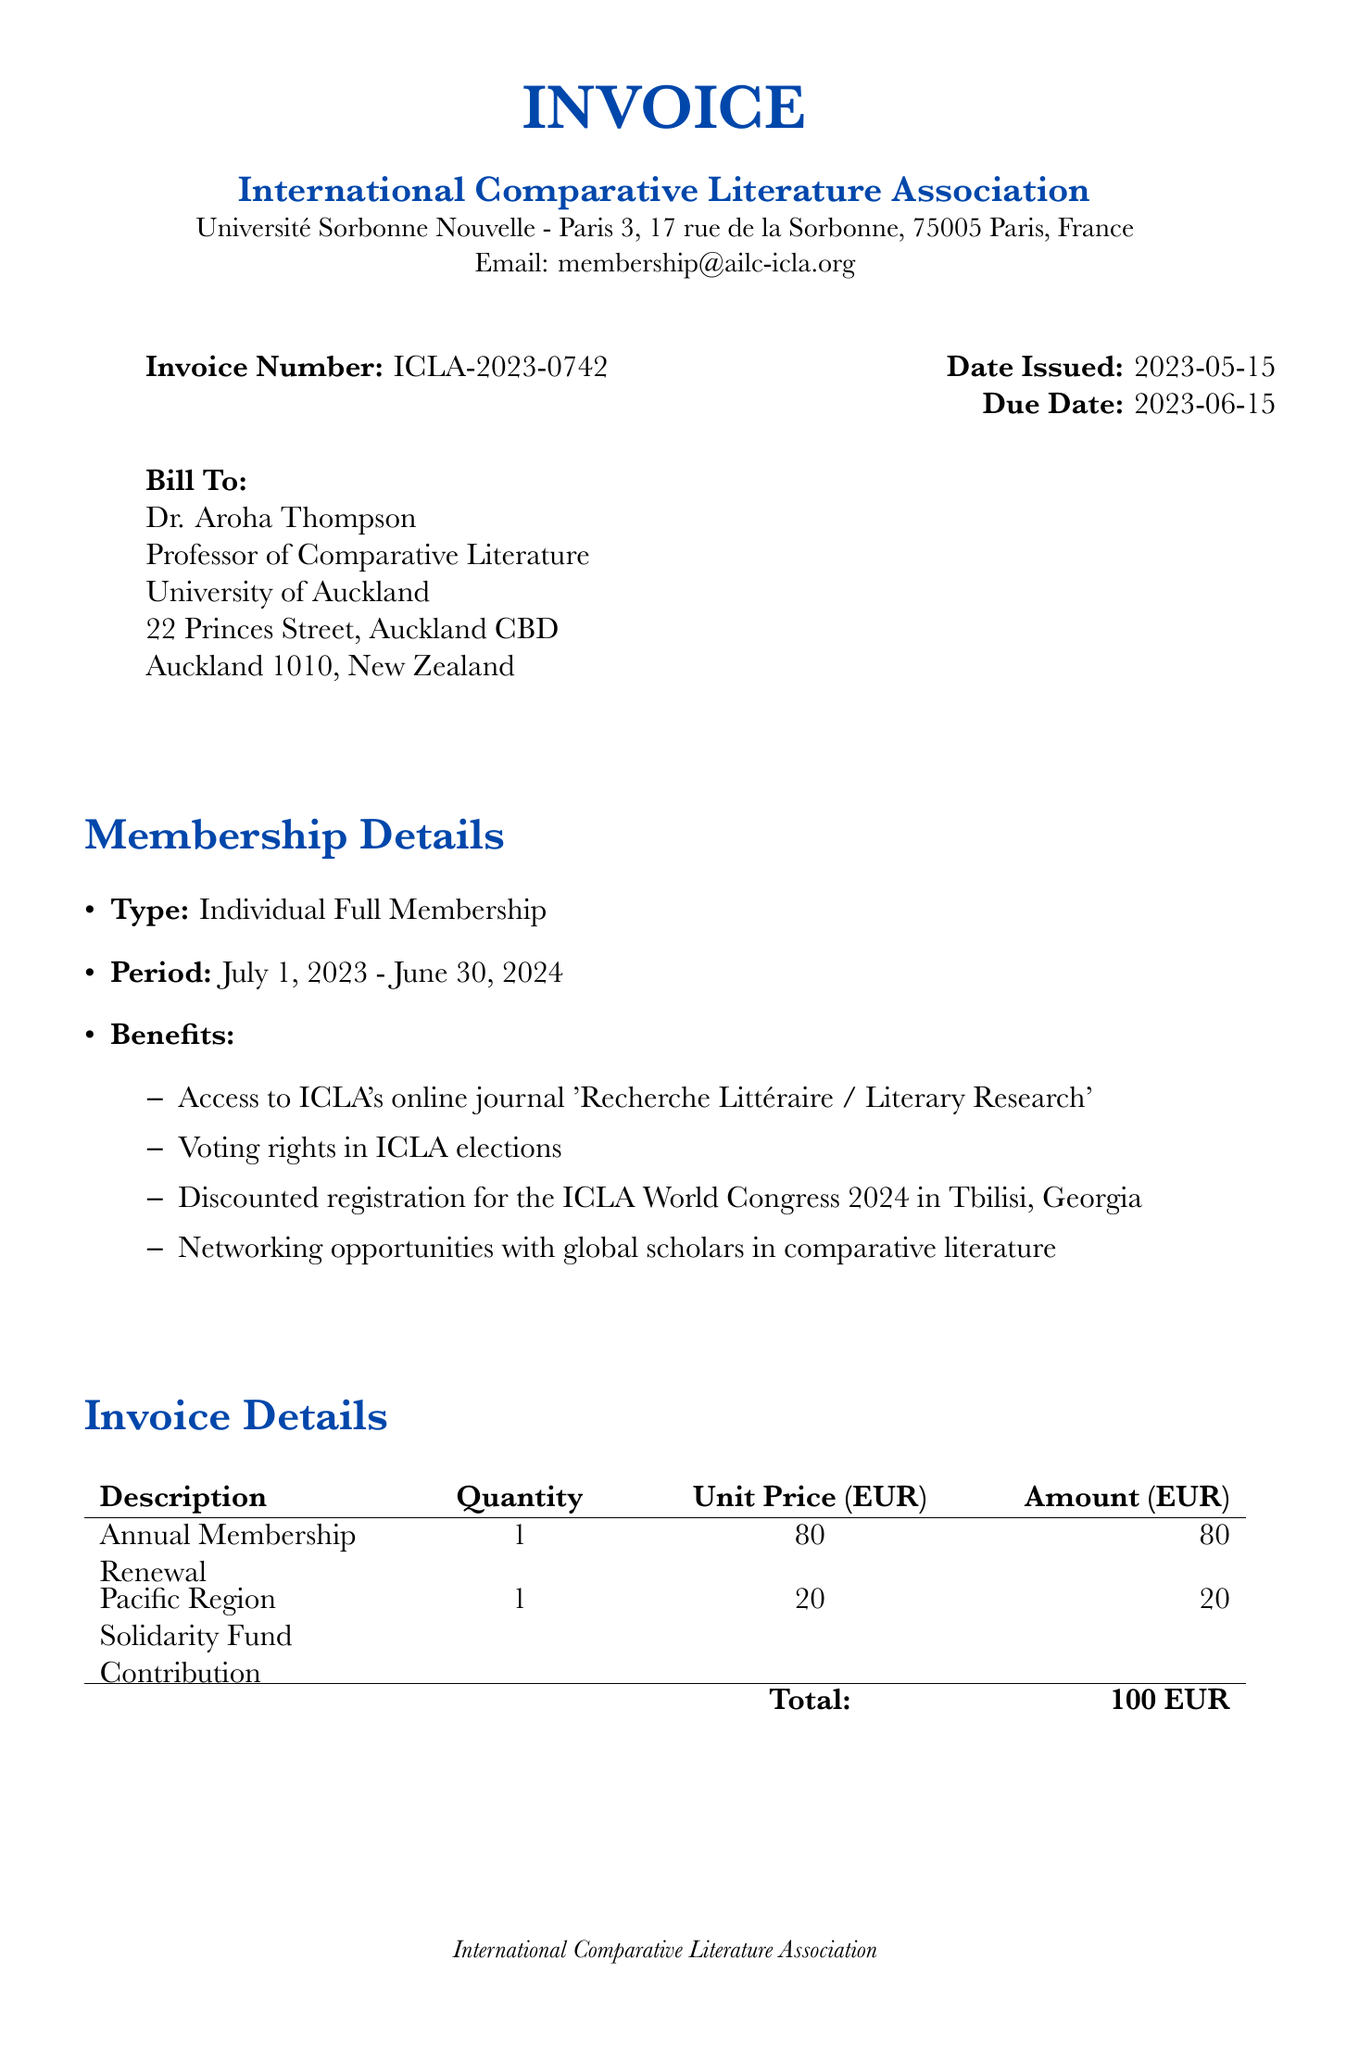What is the invoice number? The invoice number is a specific identifier for the document, presented in the header section.
Answer: ICLA-2023-0742 Who is the invoice billed to? The name of the individual or entity the invoice is addressed to is listed under the "Bill To" section.
Answer: Dr. Aroha Thompson What is the total amount due? The total amount is the sum of all line item amounts listed at the bottom of the invoice.
Answer: 100 EUR What is the due date for the invoice? The due date indicates when the payment is required and is prominently displayed in the document.
Answer: 2023-06-15 What is one of the benefits of membership? Benefits are listed under the membership details and provide incentives for joining the organization.
Answer: Access to ICLA's online journal 'Recherche Littéraire / Literary Research' What payment method requires the use of an IBAN? This question requires the identification of the payment method that utilizes international bank account numbering.
Answer: Bank Transfer How long is the membership period? The membership period defines the duration for which the membership is valid, specified in the document.
Answer: July 1, 2023 - June 30, 2024 What is the email address for queries? The document includes a contact method for any questions regarding the invoice.
Answer: membership@ailc-icla.org What type of membership is this invoice for? The type of membership can be found in the membership details section of the invoice.
Answer: Individual Full Membership 